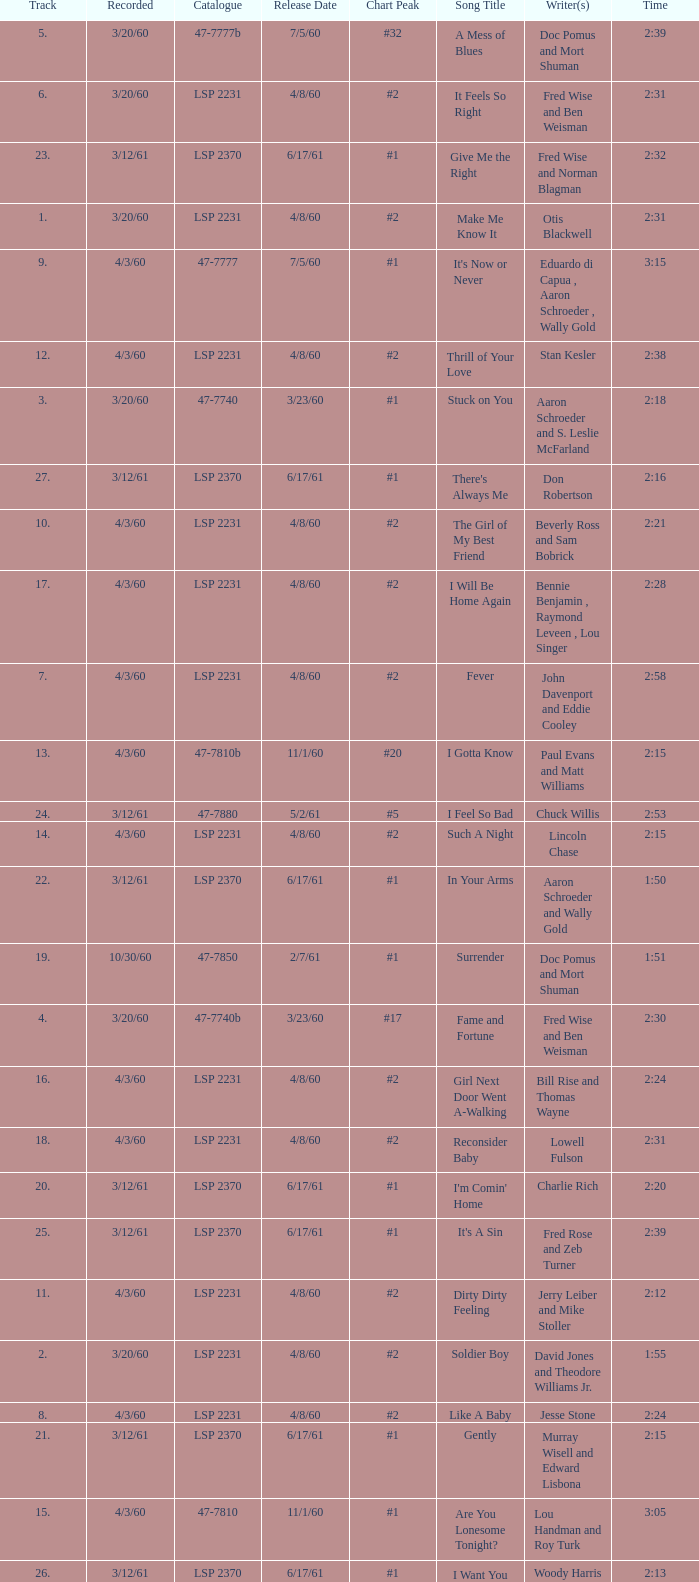On songs with track numbers smaller than number 17 and catalogues of LSP 2231, who are the writer(s)? Otis Blackwell, David Jones and Theodore Williams Jr., Fred Wise and Ben Weisman, John Davenport and Eddie Cooley, Jesse Stone, Beverly Ross and Sam Bobrick, Jerry Leiber and Mike Stoller, Stan Kesler, Lincoln Chase, Bill Rise and Thomas Wayne. 